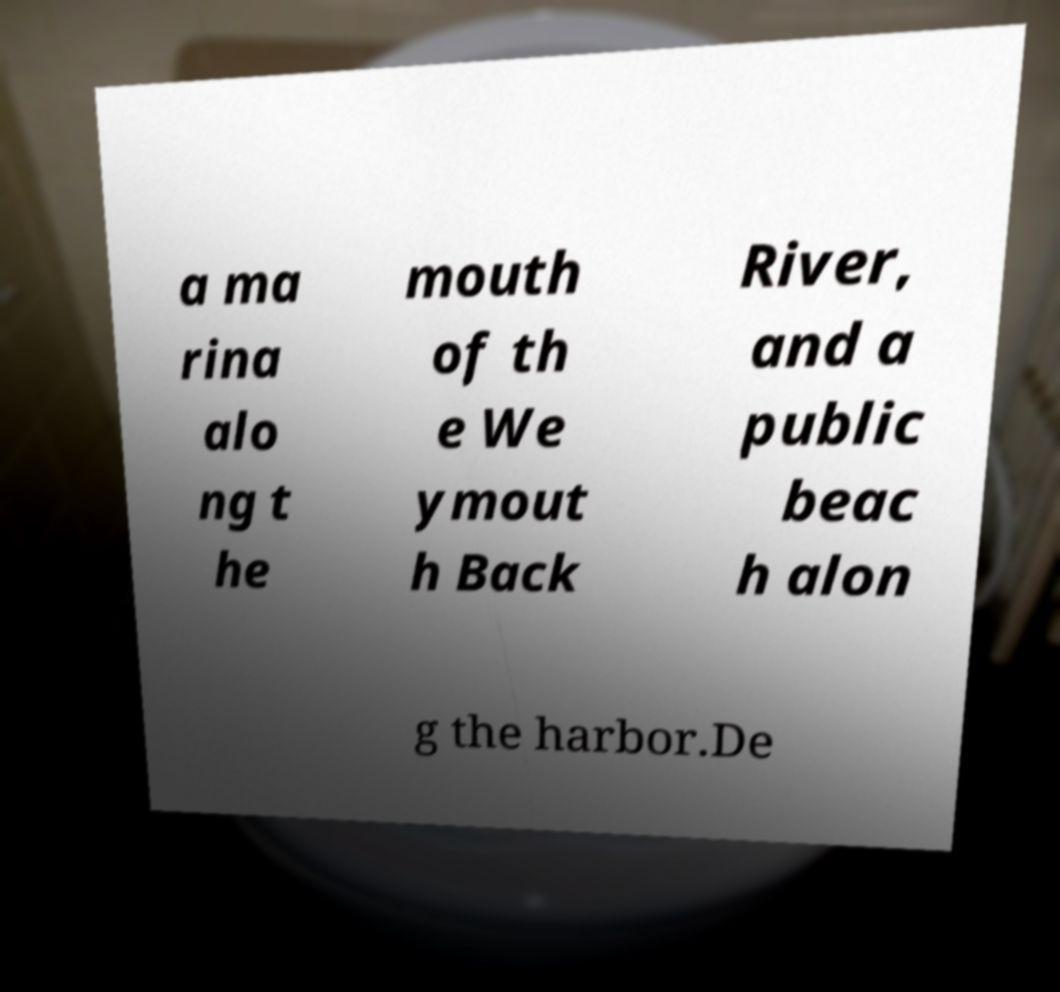What messages or text are displayed in this image? I need them in a readable, typed format. a ma rina alo ng t he mouth of th e We ymout h Back River, and a public beac h alon g the harbor.De 